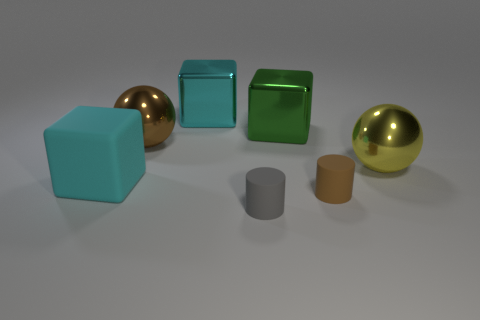Are there any other things that are made of the same material as the big brown object?
Offer a very short reply. Yes. Is the number of rubber cylinders in front of the large matte block less than the number of big shiny cylinders?
Make the answer very short. No. Is the number of objects that are in front of the cyan matte object greater than the number of metal blocks in front of the brown rubber object?
Your answer should be compact. Yes. Is there anything else that is the same color as the big matte object?
Provide a succinct answer. Yes. There is a tiny cylinder that is to the right of the large green metallic thing; what is it made of?
Provide a short and direct response. Rubber. Does the gray cylinder have the same size as the brown rubber cylinder?
Ensure brevity in your answer.  Yes. What number of other things are the same size as the brown ball?
Your answer should be very brief. 4. What shape is the tiny matte thing that is behind the matte object that is in front of the tiny matte thing that is right of the gray matte thing?
Your answer should be compact. Cylinder. How many objects are shiny spheres on the right side of the tiny gray object or spheres that are on the left side of the yellow sphere?
Your answer should be compact. 2. What is the size of the cyan object behind the cyan thing that is in front of the large cyan metallic object?
Your answer should be compact. Large. 